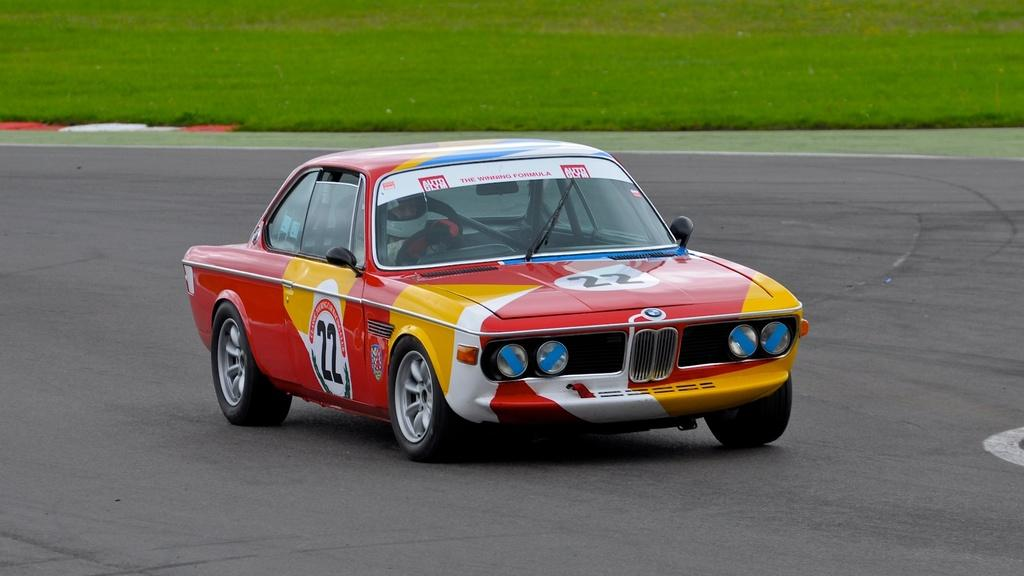What is the man in the image doing? The man is sitting inside a car in the image. Where is the car located in the image? The car is in the center of the image. What can be seen at the bottom of the image? There is a road and the ground visible at the bottom of the image. What time does the clock on the dashboard show in the image? There is no clock visible in the image, so we cannot determine the time. 